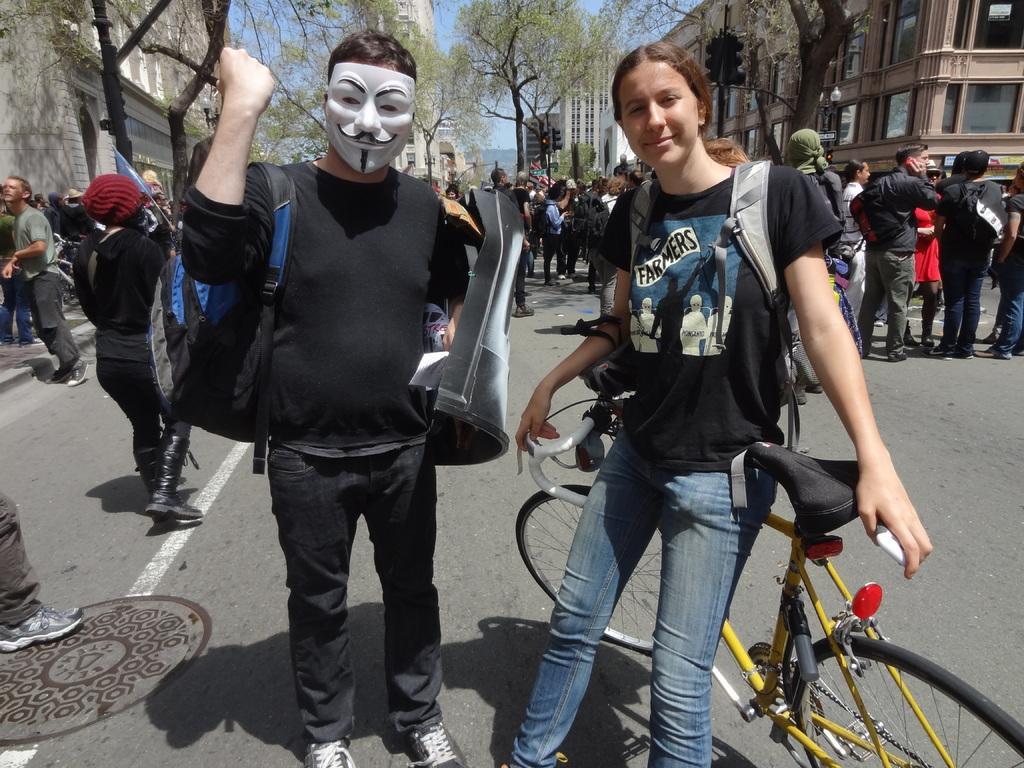Can you describe this image briefly? In this picture we can see group of people standing, in the foreground of the picture there is a man wearing black color dress, also wearing mask, carrying bag and in the background of the picture there are some trees, buildings. 